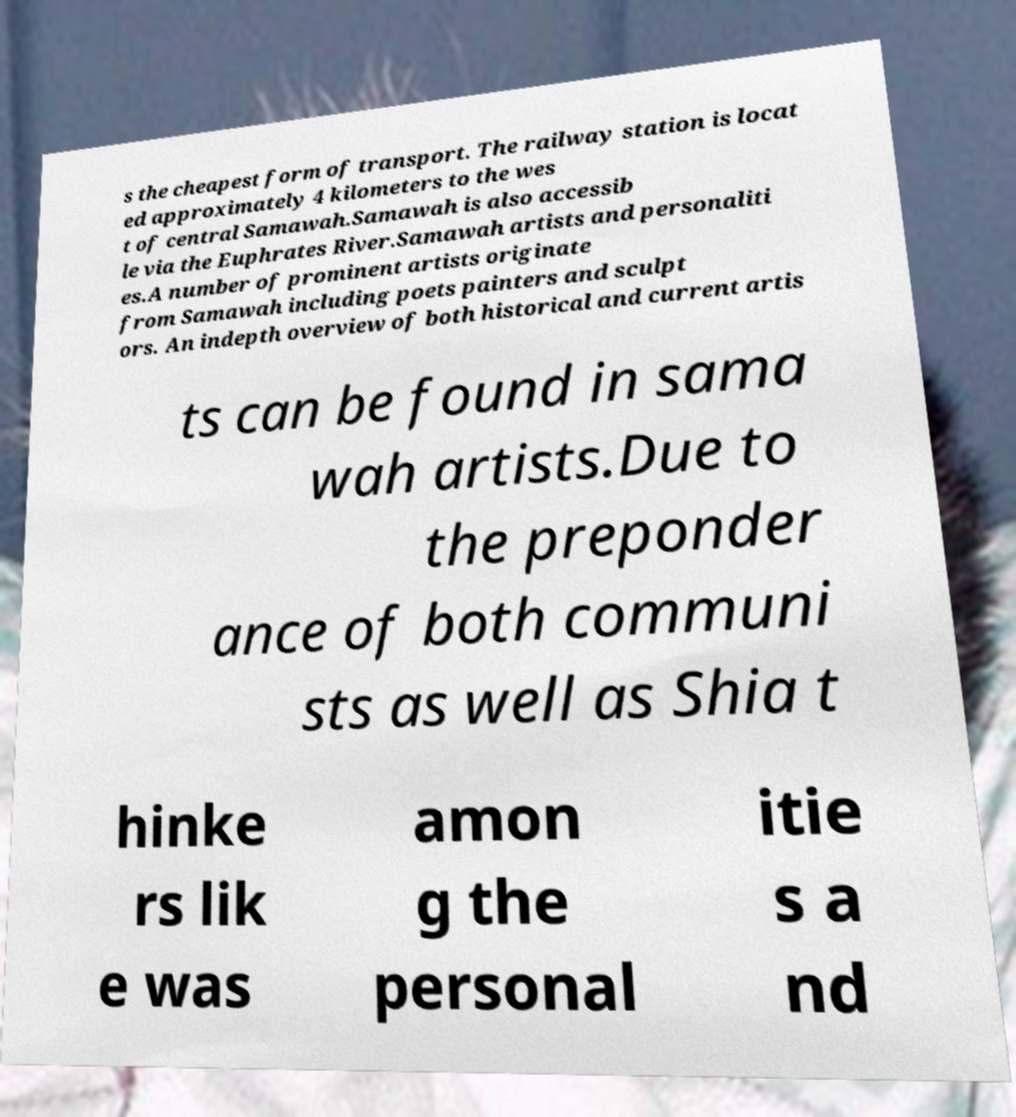Could you assist in decoding the text presented in this image and type it out clearly? s the cheapest form of transport. The railway station is locat ed approximately 4 kilometers to the wes t of central Samawah.Samawah is also accessib le via the Euphrates River.Samawah artists and personaliti es.A number of prominent artists originate from Samawah including poets painters and sculpt ors. An indepth overview of both historical and current artis ts can be found in sama wah artists.Due to the preponder ance of both communi sts as well as Shia t hinke rs lik e was amon g the personal itie s a nd 